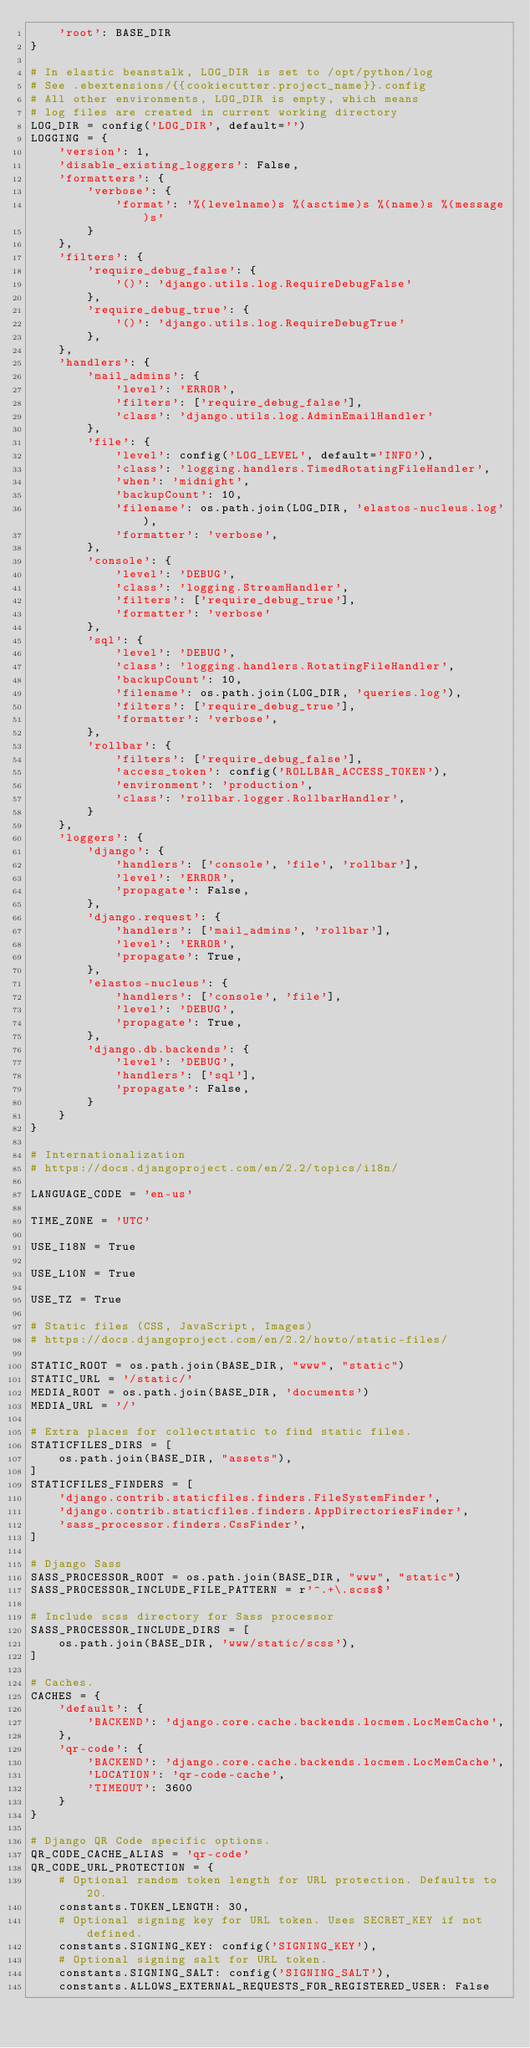Convert code to text. <code><loc_0><loc_0><loc_500><loc_500><_Python_>    'root': BASE_DIR
}

# In elastic beanstalk, LOG_DIR is set to /opt/python/log
# See .ebextensions/{{cookiecutter.project_name}}.config
# All other environments, LOG_DIR is empty, which means
# log files are created in current working directory
LOG_DIR = config('LOG_DIR', default='')
LOGGING = {
    'version': 1,
    'disable_existing_loggers': False,
    'formatters': {
        'verbose': {
            'format': '%(levelname)s %(asctime)s %(name)s %(message)s'
        }
    },
    'filters': {
        'require_debug_false': {
            '()': 'django.utils.log.RequireDebugFalse'
        },
        'require_debug_true': {
            '()': 'django.utils.log.RequireDebugTrue'
        },
    },
    'handlers': {
        'mail_admins': {
            'level': 'ERROR',
            'filters': ['require_debug_false'],
            'class': 'django.utils.log.AdminEmailHandler'
        },
        'file': {
            'level': config('LOG_LEVEL', default='INFO'),
            'class': 'logging.handlers.TimedRotatingFileHandler',
            'when': 'midnight',
            'backupCount': 10,
            'filename': os.path.join(LOG_DIR, 'elastos-nucleus.log'),
            'formatter': 'verbose',
        },
        'console': {
            'level': 'DEBUG',
            'class': 'logging.StreamHandler',
            'filters': ['require_debug_true'],
            'formatter': 'verbose'
        },
        'sql': {
            'level': 'DEBUG',
            'class': 'logging.handlers.RotatingFileHandler',
            'backupCount': 10,
            'filename': os.path.join(LOG_DIR, 'queries.log'),
            'filters': ['require_debug_true'],
            'formatter': 'verbose',
        },
        'rollbar': {
            'filters': ['require_debug_false'],
            'access_token': config('ROLLBAR_ACCESS_TOKEN'),
            'environment': 'production',
            'class': 'rollbar.logger.RollbarHandler',
        }
    },
    'loggers': {
        'django': {
            'handlers': ['console', 'file', 'rollbar'],
            'level': 'ERROR',
            'propagate': False,
        },
        'django.request': {
            'handlers': ['mail_admins', 'rollbar'],
            'level': 'ERROR',
            'propagate': True,
        },
        'elastos-nucleus': {
            'handlers': ['console', 'file'],
            'level': 'DEBUG',
            'propagate': True,
        },
        'django.db.backends': {
            'level': 'DEBUG',
            'handlers': ['sql'],
            'propagate': False,
        }
    }
}

# Internationalization
# https://docs.djangoproject.com/en/2.2/topics/i18n/

LANGUAGE_CODE = 'en-us'

TIME_ZONE = 'UTC'

USE_I18N = True

USE_L10N = True

USE_TZ = True

# Static files (CSS, JavaScript, Images)
# https://docs.djangoproject.com/en/2.2/howto/static-files/

STATIC_ROOT = os.path.join(BASE_DIR, "www", "static")
STATIC_URL = '/static/'
MEDIA_ROOT = os.path.join(BASE_DIR, 'documents')
MEDIA_URL = '/'

# Extra places for collectstatic to find static files.
STATICFILES_DIRS = [
    os.path.join(BASE_DIR, "assets"),
]
STATICFILES_FINDERS = [
    'django.contrib.staticfiles.finders.FileSystemFinder',
    'django.contrib.staticfiles.finders.AppDirectoriesFinder',
    'sass_processor.finders.CssFinder',
]

# Django Sass
SASS_PROCESSOR_ROOT = os.path.join(BASE_DIR, "www", "static")
SASS_PROCESSOR_INCLUDE_FILE_PATTERN = r'^.+\.scss$'

# Include scss directory for Sass processor
SASS_PROCESSOR_INCLUDE_DIRS = [
    os.path.join(BASE_DIR, 'www/static/scss'),
]

# Caches.
CACHES = {
    'default': {
        'BACKEND': 'django.core.cache.backends.locmem.LocMemCache',
    },
    'qr-code': {
        'BACKEND': 'django.core.cache.backends.locmem.LocMemCache',
        'LOCATION': 'qr-code-cache',
        'TIMEOUT': 3600
    }
}

# Django QR Code specific options.
QR_CODE_CACHE_ALIAS = 'qr-code'
QR_CODE_URL_PROTECTION = {
    # Optional random token length for URL protection. Defaults to 20.
    constants.TOKEN_LENGTH: 30,
    # Optional signing key for URL token. Uses SECRET_KEY if not defined.
    constants.SIGNING_KEY: config('SIGNING_KEY'),
    # Optional signing salt for URL token.
    constants.SIGNING_SALT: config('SIGNING_SALT'),
    constants.ALLOWS_EXTERNAL_REQUESTS_FOR_REGISTERED_USER: False</code> 